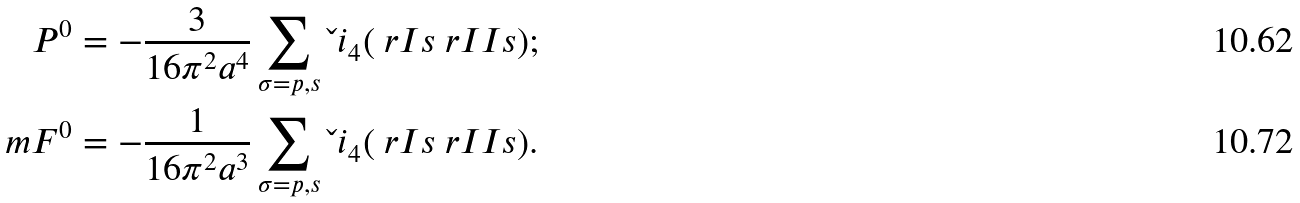<formula> <loc_0><loc_0><loc_500><loc_500>P ^ { 0 } & = - \frac { 3 } { 1 6 \pi ^ { 2 } a ^ { 4 } } \sum _ { \sigma = p , s } \L i _ { 4 } ( \ r I s \ r I I s ) ; \\ \ m F ^ { 0 } & = - \frac { 1 } { 1 6 \pi ^ { 2 } a ^ { 3 } } \sum _ { \sigma = p , s } \L i _ { 4 } ( \ r I s \ r I I s ) .</formula> 